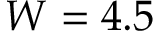Convert formula to latex. <formula><loc_0><loc_0><loc_500><loc_500>W = 4 . 5</formula> 